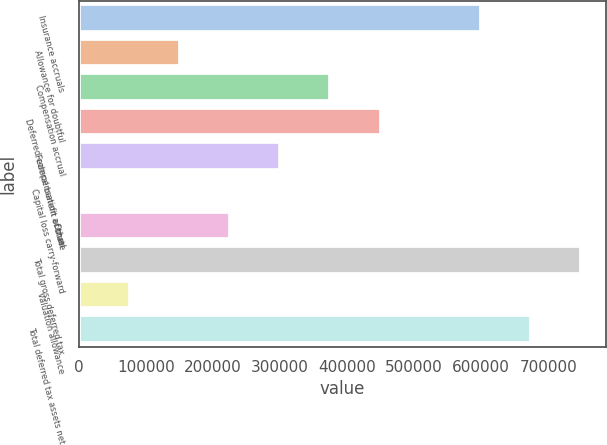Convert chart. <chart><loc_0><loc_0><loc_500><loc_500><bar_chart><fcel>Insurance accruals<fcel>Allowance for doubtful<fcel>Compensation accrual<fcel>Deferred compensation accrual<fcel>Federal benefit of state<fcel>Capital loss carry-forward<fcel>Other<fcel>Total gross deferred tax<fcel>Valuation allowance<fcel>Total deferred tax assets net<nl><fcel>599186<fcel>150879<fcel>375032<fcel>449750<fcel>300315<fcel>1443<fcel>225597<fcel>748622<fcel>76160.9<fcel>673904<nl></chart> 